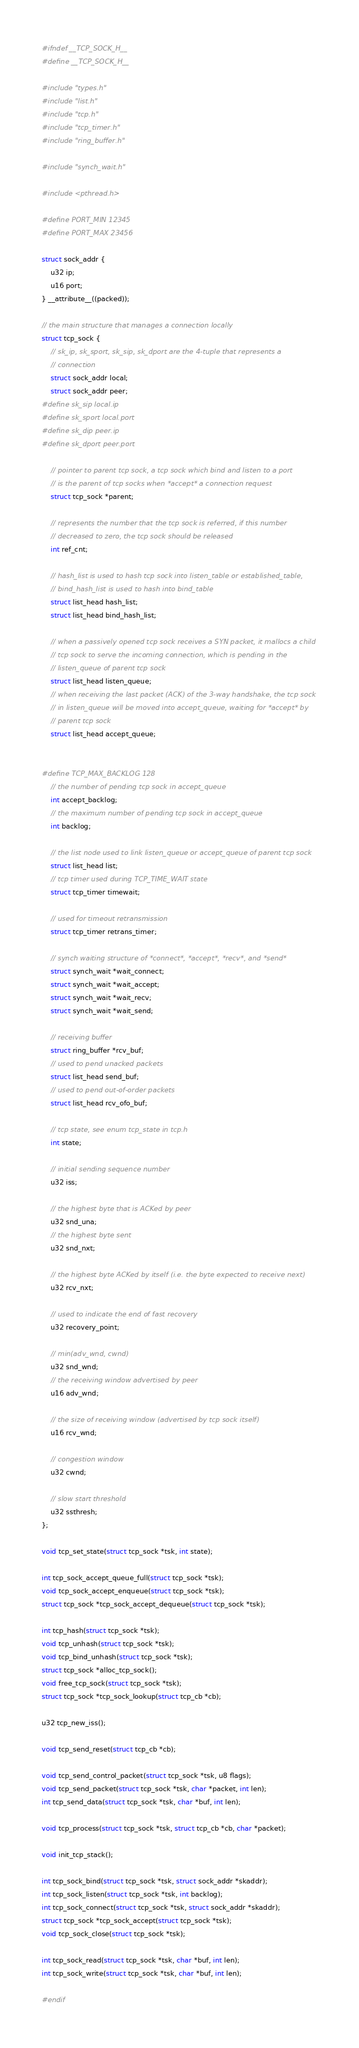<code> <loc_0><loc_0><loc_500><loc_500><_C_>#ifndef __TCP_SOCK_H__
#define __TCP_SOCK_H__

#include "types.h"
#include "list.h"
#include "tcp.h"
#include "tcp_timer.h"
#include "ring_buffer.h"

#include "synch_wait.h"

#include <pthread.h>

#define PORT_MIN	12345
#define PORT_MAX	23456

struct sock_addr {
	u32 ip;
	u16 port;
} __attribute__((packed));

// the main structure that manages a connection locally
struct tcp_sock {
	// sk_ip, sk_sport, sk_sip, sk_dport are the 4-tuple that represents a 
	// connection
	struct sock_addr local;
	struct sock_addr peer;
#define sk_sip local.ip
#define sk_sport local.port
#define sk_dip peer.ip
#define sk_dport peer.port

	// pointer to parent tcp sock, a tcp sock which bind and listen to a port 
	// is the parent of tcp socks when *accept* a connection request
	struct tcp_sock *parent;

	// represents the number that the tcp sock is referred, if this number 
	// decreased to zero, the tcp sock should be released
	int ref_cnt;

	// hash_list is used to hash tcp sock into listen_table or established_table, 
	// bind_hash_list is used to hash into bind_table
	struct list_head hash_list;
	struct list_head bind_hash_list;

	// when a passively opened tcp sock receives a SYN packet, it mallocs a child 
	// tcp sock to serve the incoming connection, which is pending in the 
	// listen_queue of parent tcp sock
	struct list_head listen_queue;
	// when receiving the last packet (ACK) of the 3-way handshake, the tcp sock 
	// in listen_queue will be moved into accept_queue, waiting for *accept* by 
	// parent tcp sock
	struct list_head accept_queue;


#define TCP_MAX_BACKLOG 128
	// the number of pending tcp sock in accept_queue
	int accept_backlog;
	// the maximum number of pending tcp sock in accept_queue
	int backlog;

	// the list node used to link listen_queue or accept_queue of parent tcp sock
	struct list_head list;
	// tcp timer used during TCP_TIME_WAIT state
	struct tcp_timer timewait;

	// used for timeout retransmission
	struct tcp_timer retrans_timer;

	// synch waiting structure of *connect*, *accept*, *recv*, and *send*
	struct synch_wait *wait_connect;
	struct synch_wait *wait_accept;
	struct synch_wait *wait_recv;
	struct synch_wait *wait_send;

	// receiving buffer
	struct ring_buffer *rcv_buf;
	// used to pend unacked packets
	struct list_head send_buf;
	// used to pend out-of-order packets
	struct list_head rcv_ofo_buf;

	// tcp state, see enum tcp_state in tcp.h
	int state;

	// initial sending sequence number
	u32 iss;

	// the highest byte that is ACKed by peer
	u32 snd_una;
	// the highest byte sent
	u32 snd_nxt;

	// the highest byte ACKed by itself (i.e. the byte expected to receive next)
	u32 rcv_nxt;

	// used to indicate the end of fast recovery
	u32 recovery_point;		

	// min(adv_wnd, cwnd)
	u32 snd_wnd;
	// the receiving window advertised by peer
	u16 adv_wnd;

	// the size of receiving window (advertised by tcp sock itself)
	u16 rcv_wnd;

	// congestion window
	u32 cwnd;

	// slow start threshold
	u32 ssthresh;
};

void tcp_set_state(struct tcp_sock *tsk, int state);

int tcp_sock_accept_queue_full(struct tcp_sock *tsk);
void tcp_sock_accept_enqueue(struct tcp_sock *tsk);
struct tcp_sock *tcp_sock_accept_dequeue(struct tcp_sock *tsk);

int tcp_hash(struct tcp_sock *tsk);
void tcp_unhash(struct tcp_sock *tsk);
void tcp_bind_unhash(struct tcp_sock *tsk);
struct tcp_sock *alloc_tcp_sock();
void free_tcp_sock(struct tcp_sock *tsk);
struct tcp_sock *tcp_sock_lookup(struct tcp_cb *cb);

u32 tcp_new_iss();

void tcp_send_reset(struct tcp_cb *cb);

void tcp_send_control_packet(struct tcp_sock *tsk, u8 flags);
void tcp_send_packet(struct tcp_sock *tsk, char *packet, int len);
int tcp_send_data(struct tcp_sock *tsk, char *buf, int len);

void tcp_process(struct tcp_sock *tsk, struct tcp_cb *cb, char *packet);

void init_tcp_stack();

int tcp_sock_bind(struct tcp_sock *tsk, struct sock_addr *skaddr);
int tcp_sock_listen(struct tcp_sock *tsk, int backlog);
int tcp_sock_connect(struct tcp_sock *tsk, struct sock_addr *skaddr);
struct tcp_sock *tcp_sock_accept(struct tcp_sock *tsk);
void tcp_sock_close(struct tcp_sock *tsk);

int tcp_sock_read(struct tcp_sock *tsk, char *buf, int len);
int tcp_sock_write(struct tcp_sock *tsk, char *buf, int len);

#endif
</code> 